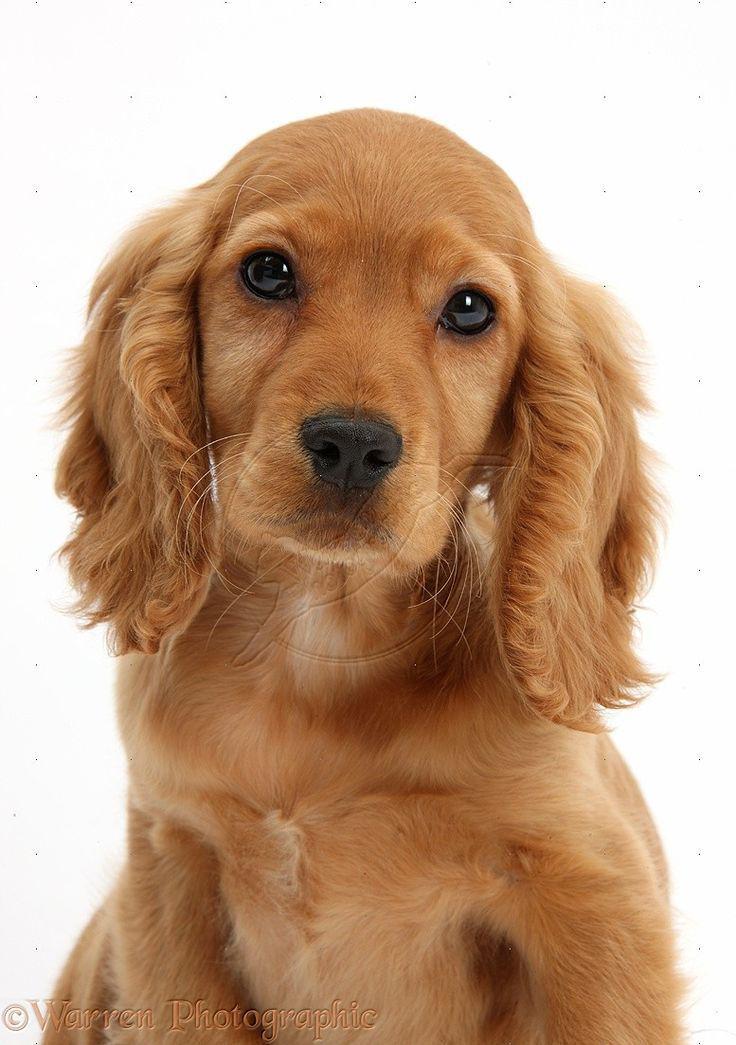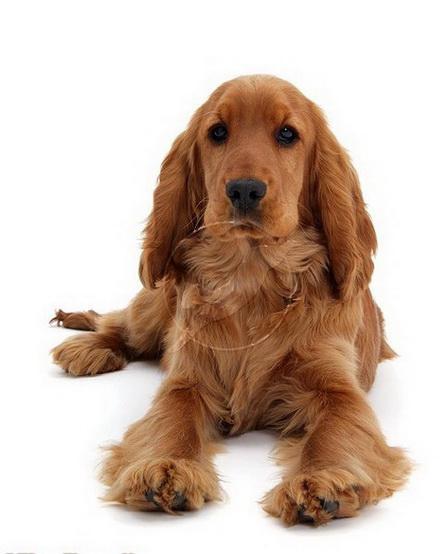The first image is the image on the left, the second image is the image on the right. Assess this claim about the two images: "Exactly two dogs are shown with background settings, each of them the same tan coloring with dark eyes, one wearing a collar and the other not". Correct or not? Answer yes or no. No. The first image is the image on the left, the second image is the image on the right. Considering the images on both sides, is "An image shows a reddish spaniel dog with its paws over a blanket-like piece of fabric." valid? Answer yes or no. No. 